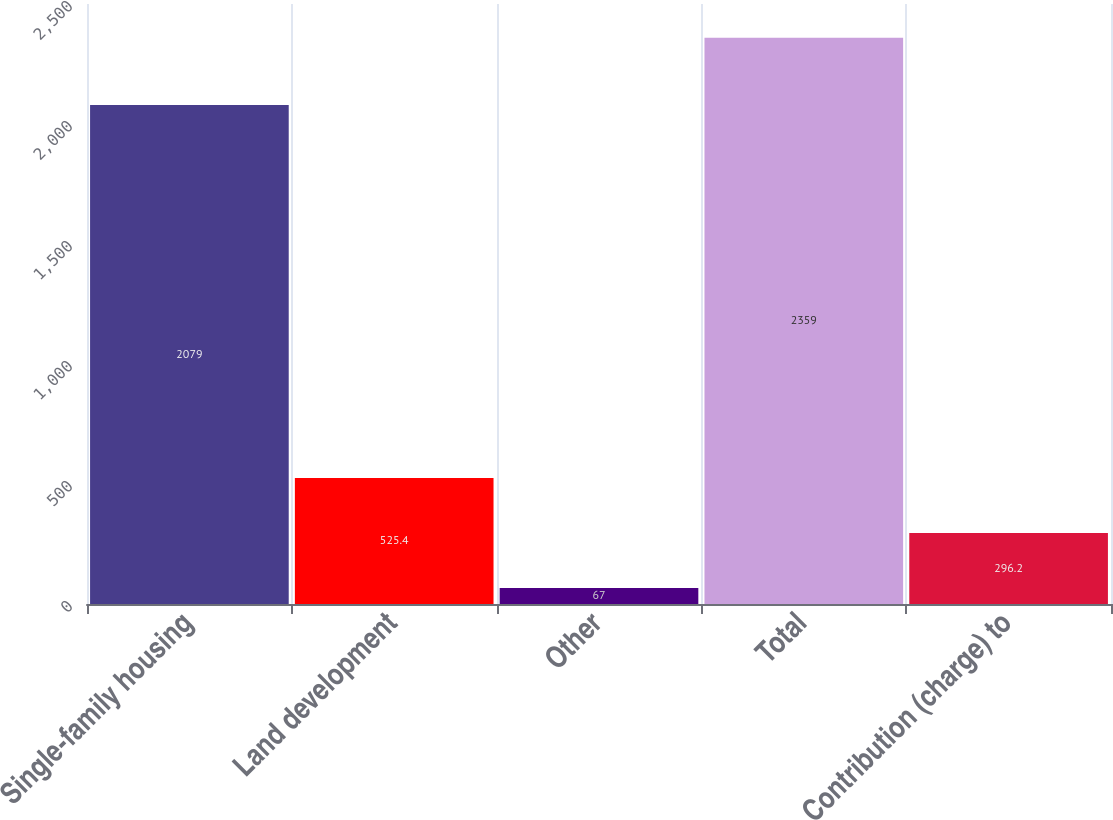Convert chart. <chart><loc_0><loc_0><loc_500><loc_500><bar_chart><fcel>Single-family housing<fcel>Land development<fcel>Other<fcel>Total<fcel>Contribution (charge) to<nl><fcel>2079<fcel>525.4<fcel>67<fcel>2359<fcel>296.2<nl></chart> 